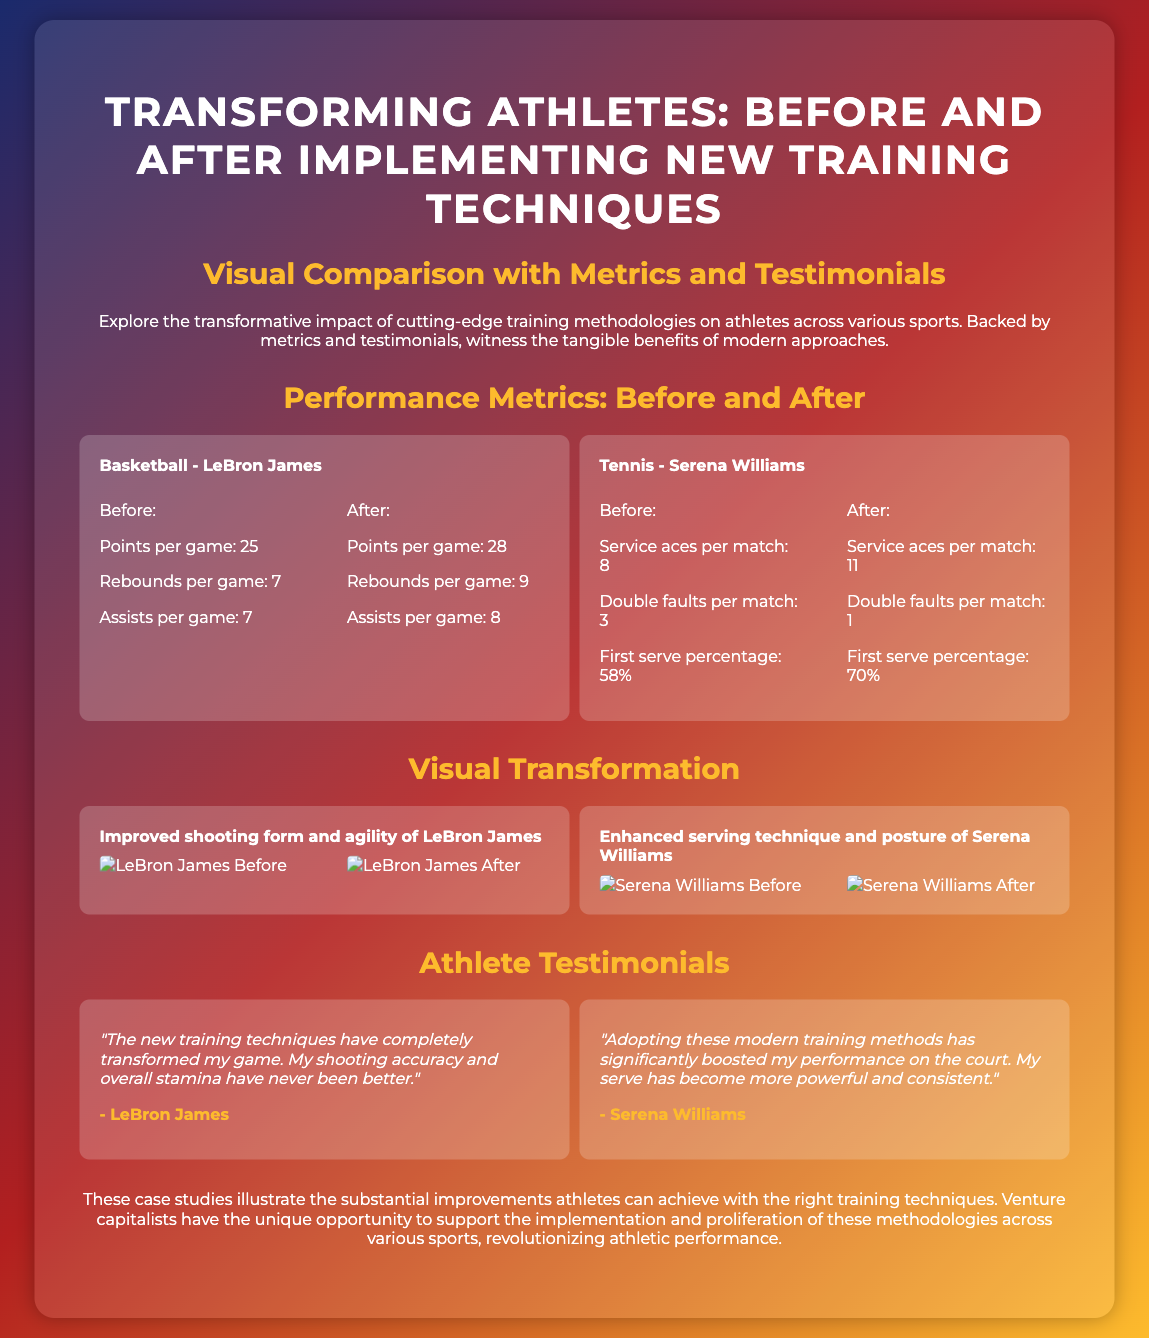What were LeBron James' points per game before the new training techniques? The document states that LeBron James averaged 25 points per game before implementing the new training techniques.
Answer: 25 What is the increase in service aces per match for Serena Williams after the training? The document shows that Serena Williams improved her service aces from 8 to 11, resulting in an increase of 3 aces per match.
Answer: 3 What does LeBron James say about the new training techniques? LeBron mentions that the new training techniques have transformed his game, improving his shooting accuracy and stamina.
Answer: Transformed my game How many rebounds per game did LeBron average after the new training? According to the metrics, LeBron averaged 9 rebounds per game after implementing the new training techniques.
Answer: 9 What percentage of first serve did Serena achieve after the training? The document indicates that Serena Williams' first serve percentage increased to 70% after the training techniques were applied.
Answer: 70% What was the biggest improvement in double faults for Serena Williams? The data shows that Serena Williams reduced her double faults from 3 to 1, indicating a decrease of 2 double faults per match.
Answer: 2 What visual transformation is highlighted for LeBron James? The poster highlights improved shooting form and agility for LeBron James as part of the visual transformation after the new training techniques.
Answer: Improved shooting form and agility What type of document is this? Based on the content and structure, this is a poster showcasing athlete transformations through new training methodologies.
Answer: Poster 